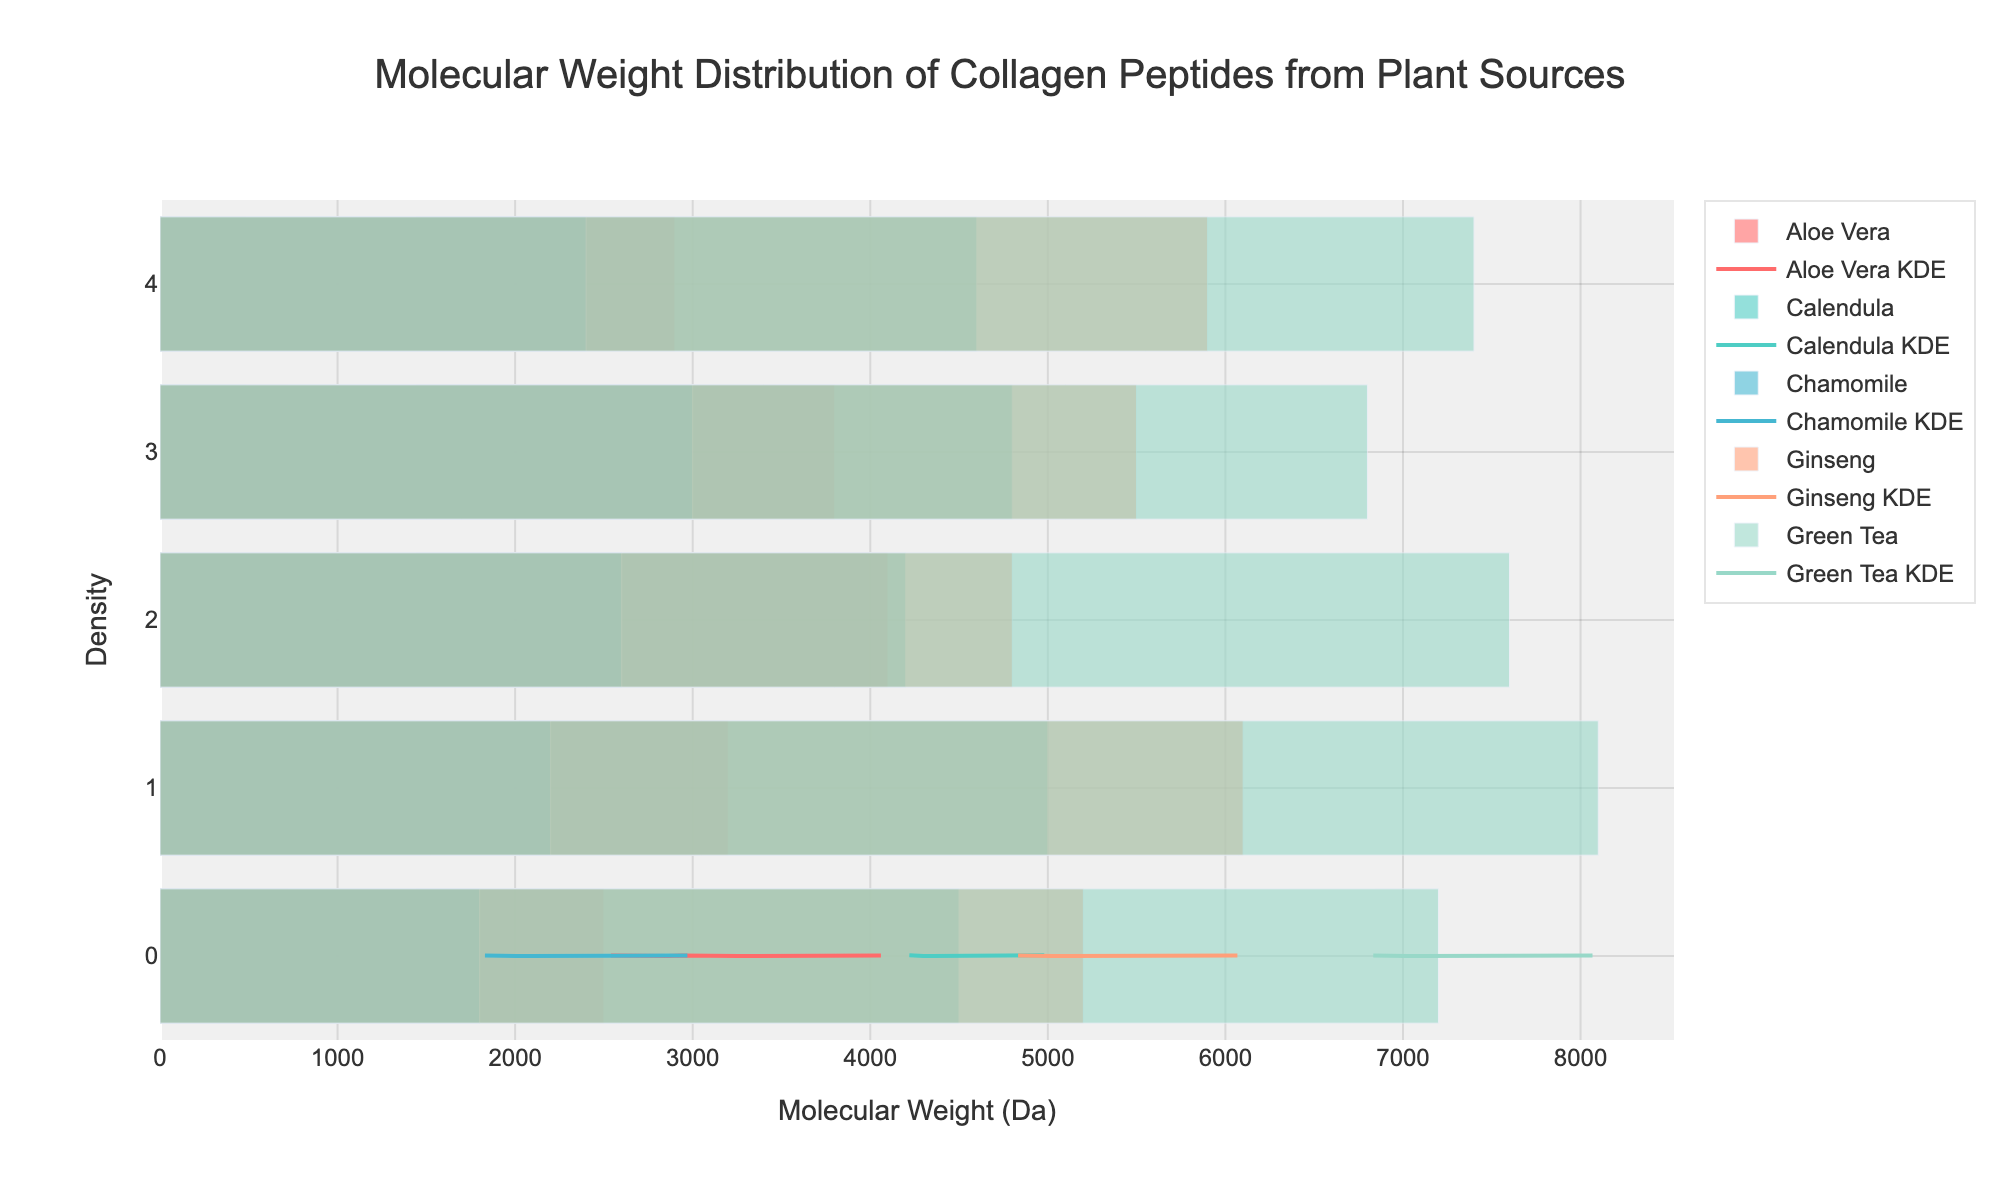What's the title of the figure? The title is usually located at the top of the figure and summarizes what the chart is about. It reads "Molecular Weight Distribution of Collagen Peptides from Plant Sources".
Answer: Molecular Weight Distribution of Collagen Peptides from Plant Sources Which plant source has the most number of data points included in the histogram? Count the number of bars or data points for each plant source. Aloe Vera, Ginseng, Chamomile, Green Tea, and Calendula each have 5 data points. Since they all have the same number of data points, there isn't one plant source with the most data points.
Answer: Multiple plant sources have the same number of data points What is the range of molecular weights for Aloe Vera? Look at the x-axis values for the bars corresponding to Aloe Vera. The molecular weights for Aloe Vera range from 2500 to 4100 Da.
Answer: 2500 to 4100 Da Which plant source has the highest molecular weight recorded? Check the highest value on the x-axis for each plant source. Green Tea has the highest molecular weight with a peak at 8100 Da.
Answer: Green Tea Compare the KDE peaks of Ginseng and Calendula. Which one has a higher peak density? Examine the KDE curves (smooth lines) for both Ginseng and Calendula. Ginseng's KDE peaks higher than Calendula's KDE.
Answer: Ginseng Which plant source shows the most spread-out distribution in molecular weights? Look for the plant with the widest range of bars along the x-axis. Green Tea covers a wide range from 6800 to 8100 Da, indicating a more spread-out distribution.
Answer: Green Tea Is the peak of Aloe Vera's KDE closer to the lower or higher end of its molecular weight range? Observe the position of the KDE curve's peak relative to the molecular weight values of Aloe Vera. The peak is closer to the lower end.
Answer: Lower end What is the common molecular weight range for Chamomile and Calendula? Identify the overlapping range on the x-axis for Chamomile and Calendula. Both ranges overlap between 1800 to 5000 Da.
Answer: 1800 to 5000 Da If you wanted to target a product with peptides around 4000 Da, which plant source(s) would be the most relevant? Look for the plant sources with KDE density and bar peaks around 4000 Da. Aloe Vera and Calendula have molecular weights around 4000 Da.
Answer: Aloe Vera and Calendula 